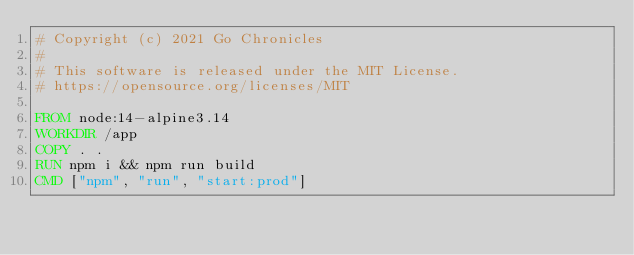Convert code to text. <code><loc_0><loc_0><loc_500><loc_500><_Dockerfile_># Copyright (c) 2021 Go Chronicles
# 
# This software is released under the MIT License.
# https://opensource.org/licenses/MIT

FROM node:14-alpine3.14
WORKDIR /app
COPY . .
RUN npm i && npm run build
CMD ["npm", "run", "start:prod"]</code> 